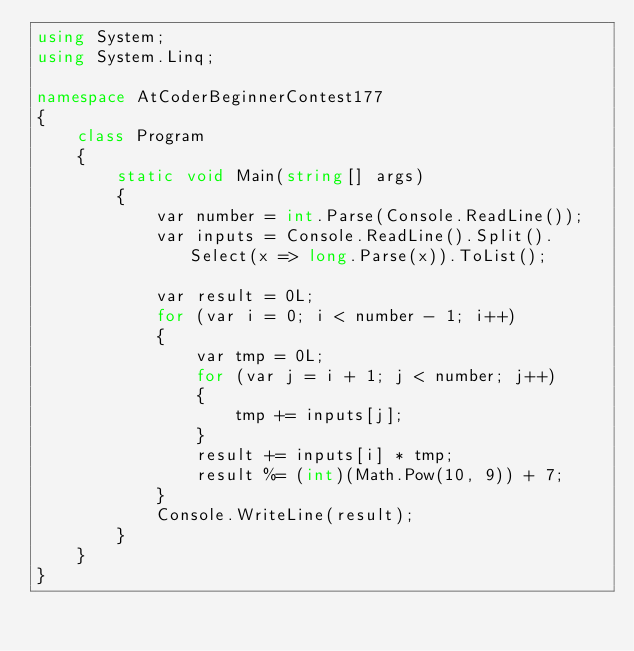<code> <loc_0><loc_0><loc_500><loc_500><_C#_>using System;
using System.Linq;

namespace AtCoderBeginnerContest177
{
	class Program
	{
		static void Main(string[] args)
		{
			var number = int.Parse(Console.ReadLine());
			var inputs = Console.ReadLine().Split().Select(x => long.Parse(x)).ToList();

			var result = 0L;
			for (var i = 0; i < number - 1; i++)
			{
				var tmp = 0L;
				for (var j = i + 1; j < number; j++)
				{
					tmp += inputs[j];
				}
				result += inputs[i] * tmp;
				result %= (int)(Math.Pow(10, 9)) + 7;
			}
			Console.WriteLine(result);
		}
	}
}
</code> 